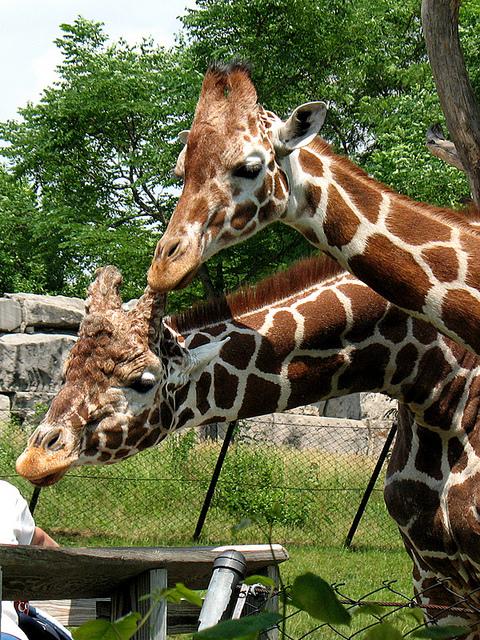How many spots can be counted?
Answer briefly. 50. Which animal looks older?
Be succinct. Left. How many people are in this picture?
Be succinct. 1. 